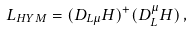Convert formula to latex. <formula><loc_0><loc_0><loc_500><loc_500>L _ { H Y M } = ( D _ { L \mu } H ) ^ { + } ( D ^ { \mu } _ { L } H ) \, ,</formula> 